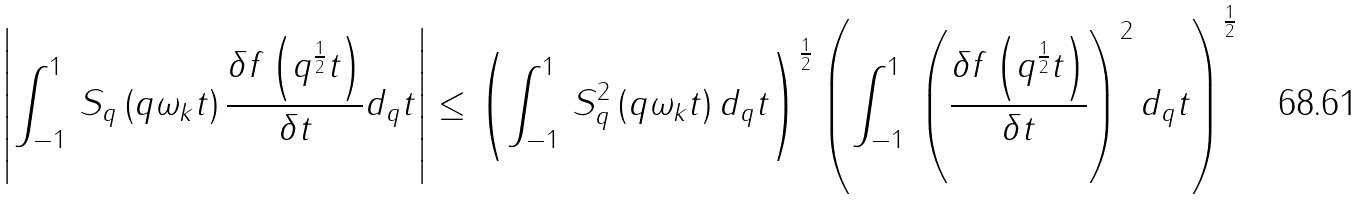Convert formula to latex. <formula><loc_0><loc_0><loc_500><loc_500>\, \left | \int _ { - 1 } ^ { 1 } \, S _ { q } \left ( q \omega _ { k } t \right ) \frac { \delta f \left ( q ^ { \frac { 1 } { 2 } } t \right ) } { \delta t } d _ { q } t \right | \leq \left ( \int _ { - 1 } ^ { 1 } \, S _ { q } ^ { 2 } \left ( q \omega _ { k } t \right ) d _ { q } t \right ) ^ { \frac { 1 } { 2 } } \left ( \int _ { - 1 } ^ { 1 } \, \left ( \frac { \delta f \left ( q ^ { \frac { 1 } { 2 } } t \right ) } { \delta t } \right ) ^ { 2 } d _ { q } t \right ) ^ { \frac { 1 } { 2 } }</formula> 